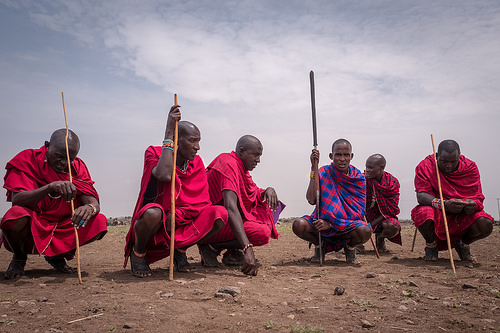<image>
Is the man to the left of the man? Yes. From this viewpoint, the man is positioned to the left side relative to the man. Is there a man to the left of the man? Yes. From this viewpoint, the man is positioned to the left side relative to the man. 